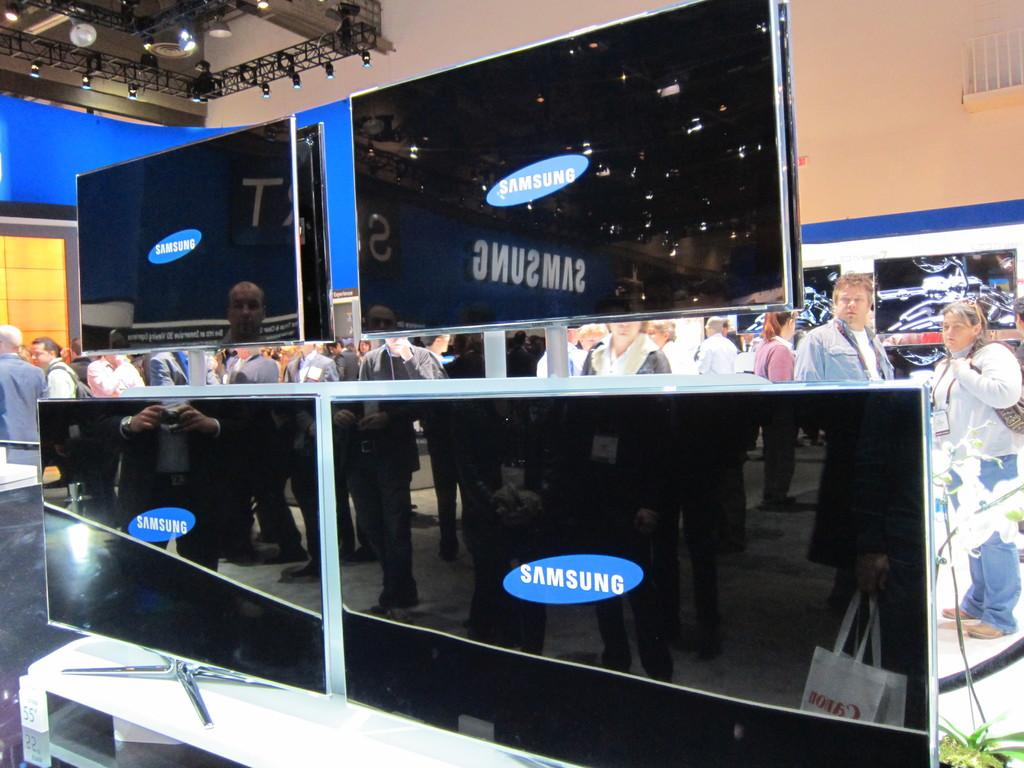Provide a one-sentence caption for the provided image. Many people are standing behind a Samsung Television display. 